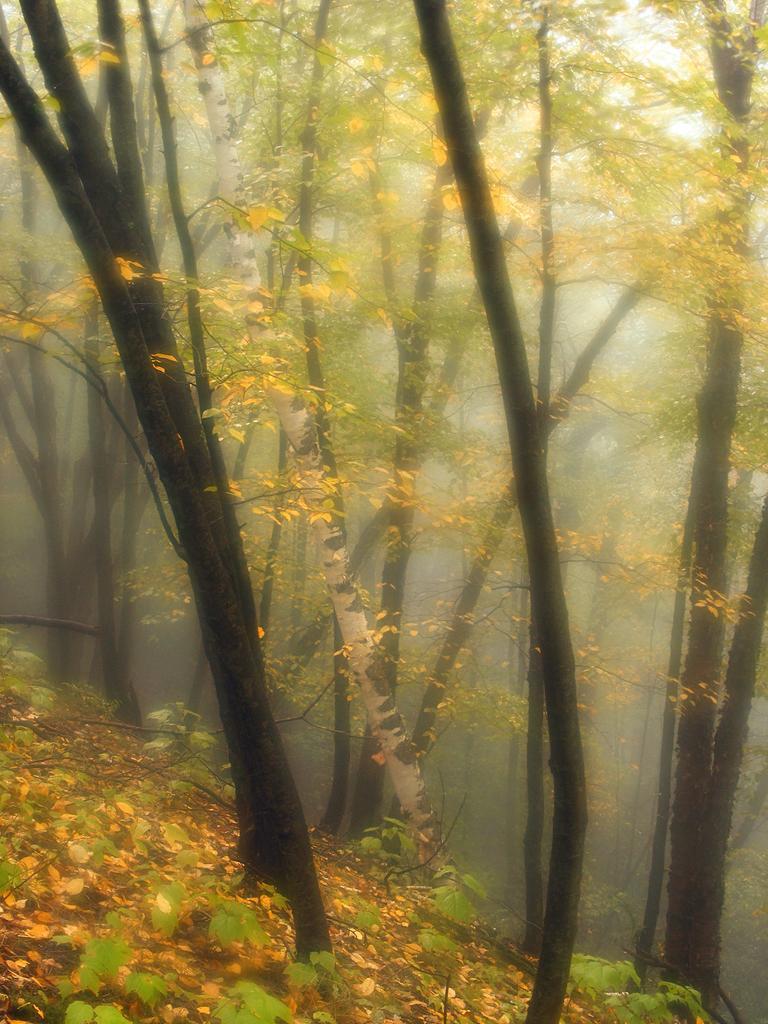Please provide a concise description of this image. In the picture I can see trees and plants. This picture is little bit blurred in the background. 